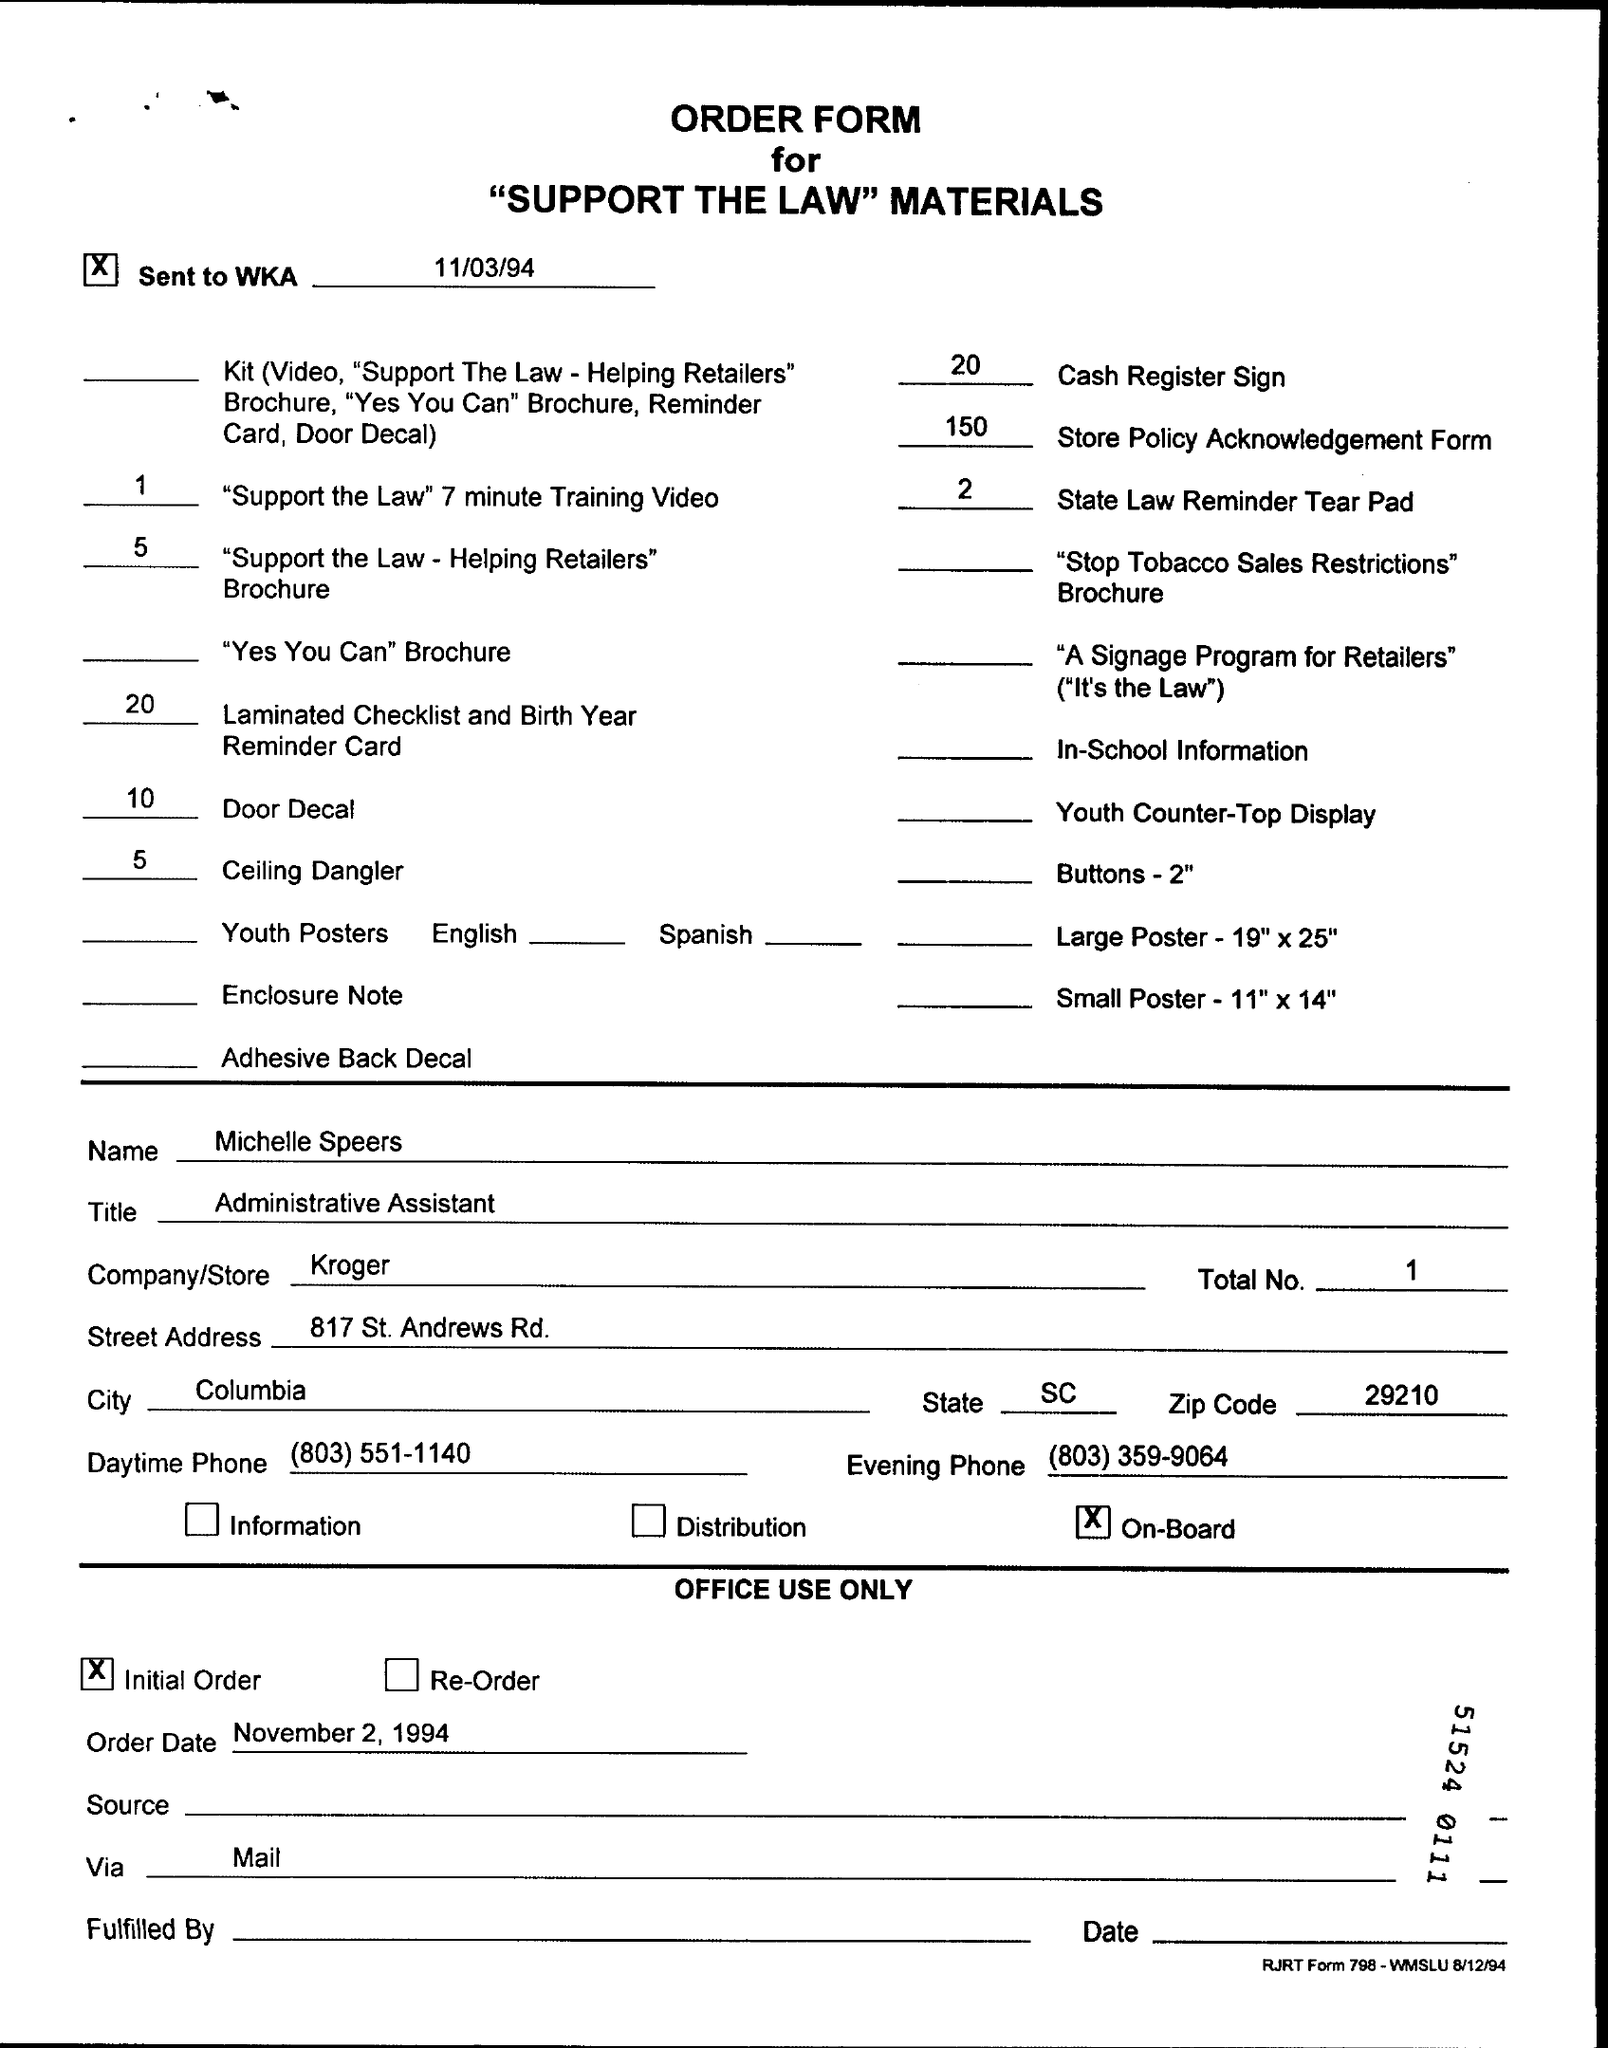Find the zip code from the page?
Offer a very short reply. 29210. What is the order date?
Provide a short and direct response. November 2, 1994. 